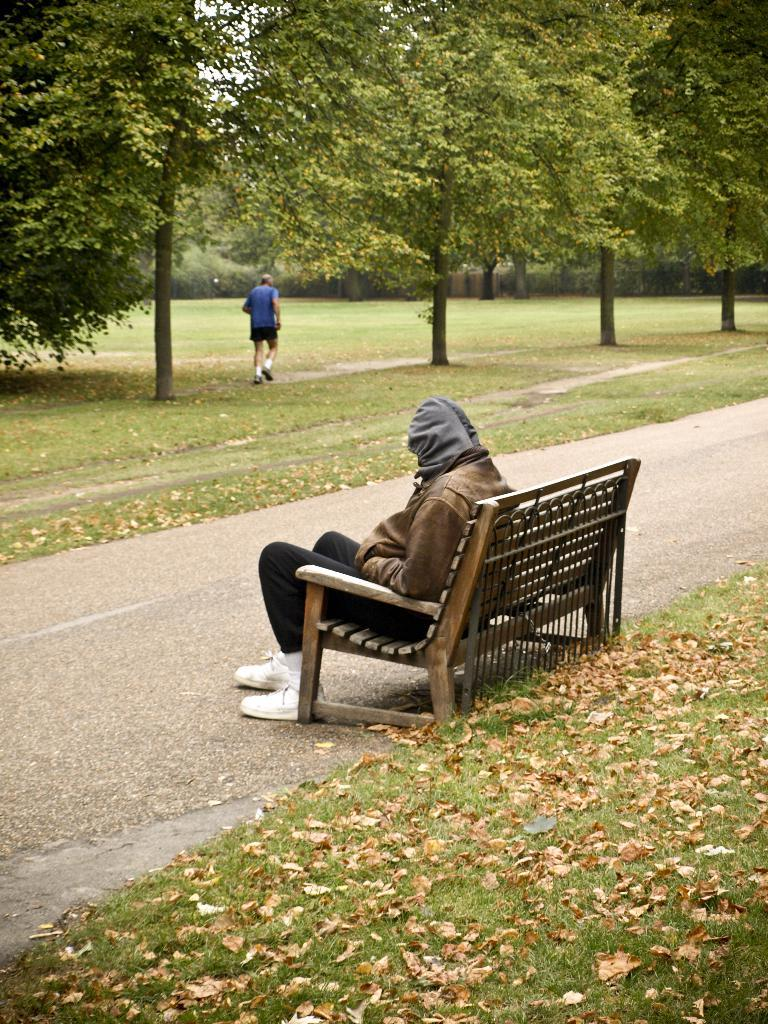What is the person in the image doing? There is a person sitting on a bench in the image. What can be seen in the background of the image? There are trees and grass in the background. Are there any other people visible in the image? Yes, there is another person in the background. What is the condition of the grass in the image? Dried leaves are present on the grass in the image. What type of queen is sitting on the bench in the image? There is no queen present in the image; it is a person sitting on the bench. Is there a sidewalk visible in the image? There is no sidewalk mentioned or visible in the image. 